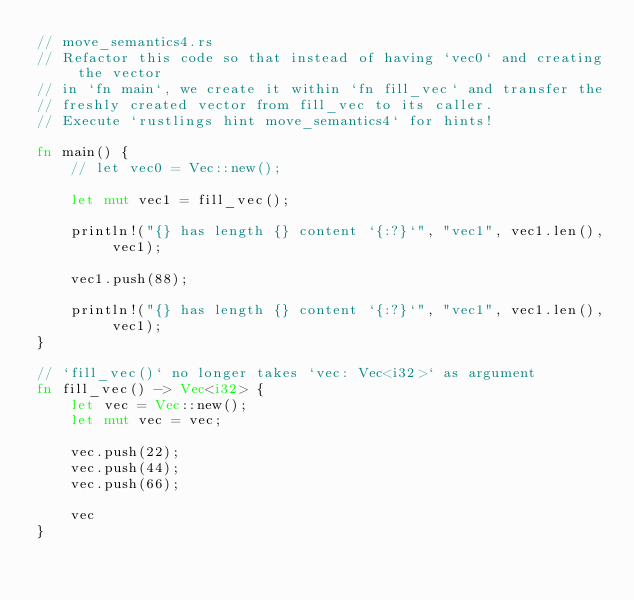<code> <loc_0><loc_0><loc_500><loc_500><_Rust_>// move_semantics4.rs
// Refactor this code so that instead of having `vec0` and creating the vector
// in `fn main`, we create it within `fn fill_vec` and transfer the
// freshly created vector from fill_vec to its caller.
// Execute `rustlings hint move_semantics4` for hints!

fn main() {
    // let vec0 = Vec::new();

    let mut vec1 = fill_vec();

    println!("{} has length {} content `{:?}`", "vec1", vec1.len(), vec1);

    vec1.push(88);

    println!("{} has length {} content `{:?}`", "vec1", vec1.len(), vec1);
}

// `fill_vec()` no longer takes `vec: Vec<i32>` as argument
fn fill_vec() -> Vec<i32> {
    let vec = Vec::new();
    let mut vec = vec;

    vec.push(22);
    vec.push(44);
    vec.push(66);

    vec
}
</code> 